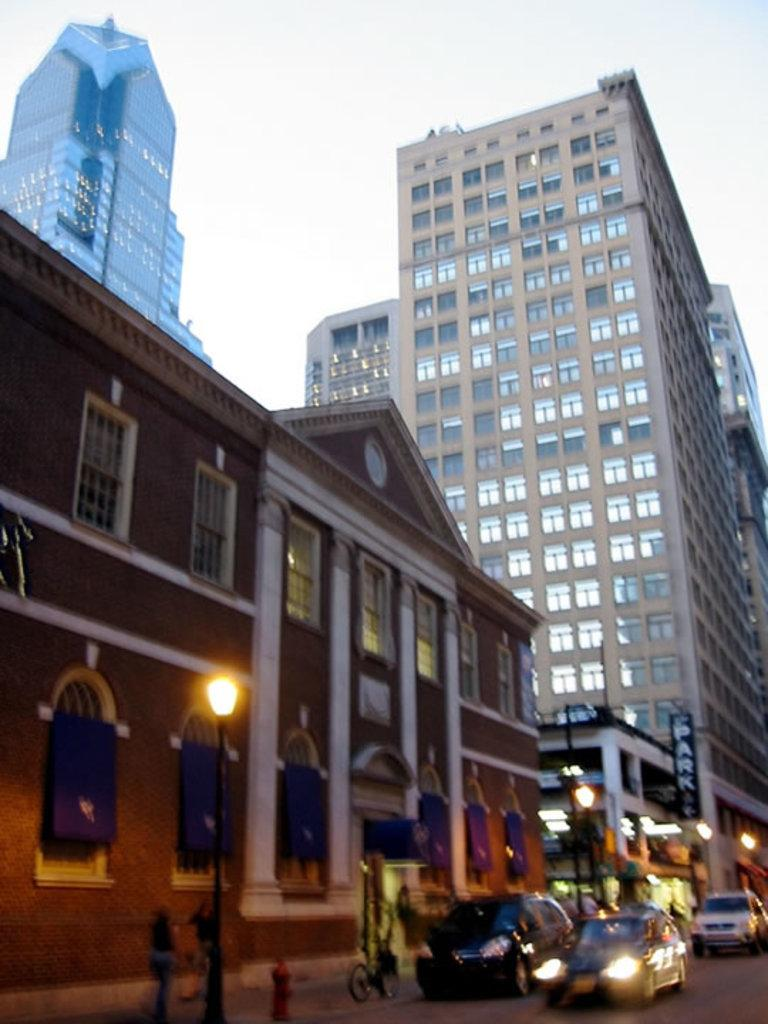What type of structure is visible in the image? There is a building in the image. What is in front of the building? There is a road in front of the building. What can be seen on the road? Vehicles and persons are present on the road. What type of infrastructure is visible along the road? Street light poles are visible in the image. What is visible at the top of the image? The sky is visible at the top of the image. Where is the cat located in the image? There is no cat present in the image. What type of market can be seen in the image? There is no market present in the image. 